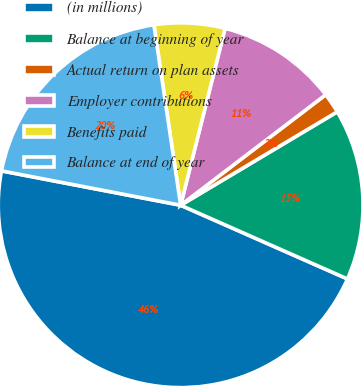Convert chart. <chart><loc_0><loc_0><loc_500><loc_500><pie_chart><fcel>(in millions)<fcel>Balance at beginning of year<fcel>Actual return on plan assets<fcel>Employer contributions<fcel>Benefits paid<fcel>Balance at end of year<nl><fcel>46.39%<fcel>15.18%<fcel>1.8%<fcel>10.72%<fcel>6.26%<fcel>19.64%<nl></chart> 